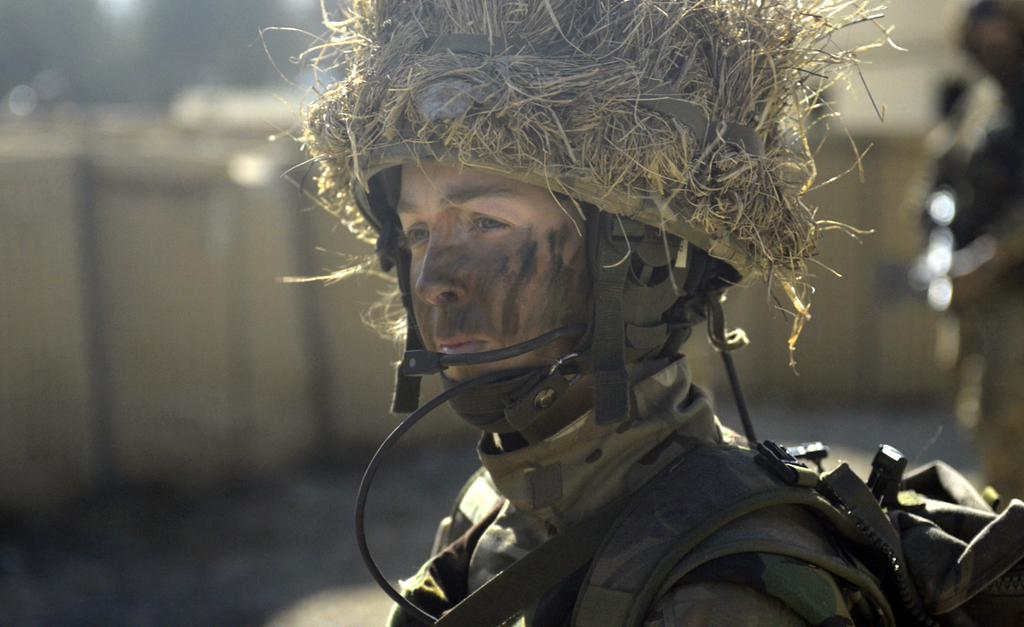Who is present in the image? There is a man in the image. What is the man wearing on his head? The man is wearing a helmet. Can you describe the background of the image? There is a person and a wall in the background of the image. What type of can is the rat holding in the image? There is no rat or can present in the image. 